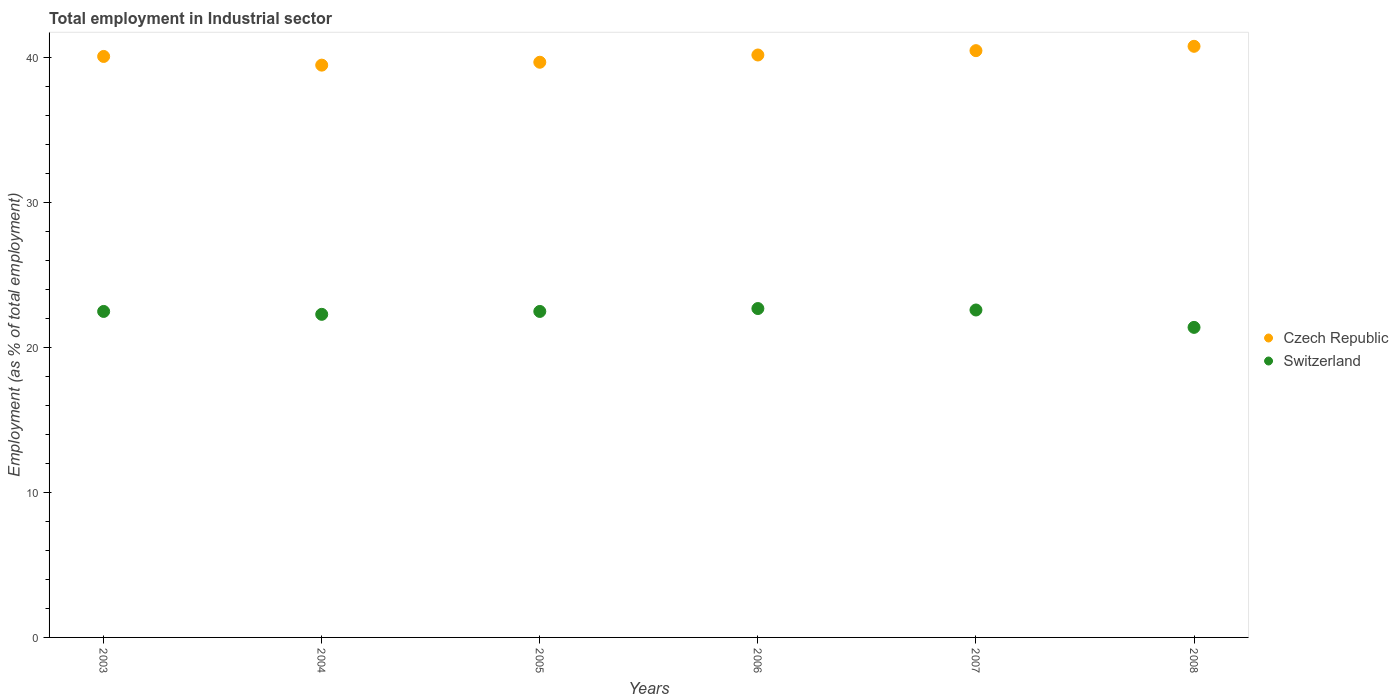What is the employment in industrial sector in Czech Republic in 2008?
Offer a very short reply. 40.8. Across all years, what is the maximum employment in industrial sector in Czech Republic?
Your response must be concise. 40.8. Across all years, what is the minimum employment in industrial sector in Switzerland?
Give a very brief answer. 21.4. In which year was the employment in industrial sector in Czech Republic maximum?
Offer a very short reply. 2008. What is the total employment in industrial sector in Czech Republic in the graph?
Offer a terse response. 240.8. What is the difference between the employment in industrial sector in Czech Republic in 2003 and that in 2008?
Your answer should be compact. -0.7. What is the difference between the employment in industrial sector in Czech Republic in 2004 and the employment in industrial sector in Switzerland in 2008?
Offer a very short reply. 18.1. What is the average employment in industrial sector in Czech Republic per year?
Provide a short and direct response. 40.13. In the year 2006, what is the difference between the employment in industrial sector in Czech Republic and employment in industrial sector in Switzerland?
Make the answer very short. 17.5. What is the ratio of the employment in industrial sector in Czech Republic in 2004 to that in 2005?
Give a very brief answer. 0.99. What is the difference between the highest and the second highest employment in industrial sector in Czech Republic?
Your answer should be compact. 0.3. What is the difference between the highest and the lowest employment in industrial sector in Switzerland?
Ensure brevity in your answer.  1.3. Is the sum of the employment in industrial sector in Switzerland in 2003 and 2005 greater than the maximum employment in industrial sector in Czech Republic across all years?
Provide a short and direct response. Yes. Is the employment in industrial sector in Switzerland strictly greater than the employment in industrial sector in Czech Republic over the years?
Make the answer very short. No. Is the employment in industrial sector in Czech Republic strictly less than the employment in industrial sector in Switzerland over the years?
Your response must be concise. No. How many years are there in the graph?
Offer a terse response. 6. Does the graph contain grids?
Make the answer very short. No. Where does the legend appear in the graph?
Your response must be concise. Center right. How many legend labels are there?
Give a very brief answer. 2. What is the title of the graph?
Provide a short and direct response. Total employment in Industrial sector. Does "Morocco" appear as one of the legend labels in the graph?
Provide a short and direct response. No. What is the label or title of the Y-axis?
Your answer should be very brief. Employment (as % of total employment). What is the Employment (as % of total employment) in Czech Republic in 2003?
Your response must be concise. 40.1. What is the Employment (as % of total employment) of Czech Republic in 2004?
Your response must be concise. 39.5. What is the Employment (as % of total employment) of Switzerland in 2004?
Provide a succinct answer. 22.3. What is the Employment (as % of total employment) of Czech Republic in 2005?
Ensure brevity in your answer.  39.7. What is the Employment (as % of total employment) of Czech Republic in 2006?
Give a very brief answer. 40.2. What is the Employment (as % of total employment) of Switzerland in 2006?
Ensure brevity in your answer.  22.7. What is the Employment (as % of total employment) of Czech Republic in 2007?
Keep it short and to the point. 40.5. What is the Employment (as % of total employment) of Switzerland in 2007?
Offer a very short reply. 22.6. What is the Employment (as % of total employment) in Czech Republic in 2008?
Ensure brevity in your answer.  40.8. What is the Employment (as % of total employment) in Switzerland in 2008?
Ensure brevity in your answer.  21.4. Across all years, what is the maximum Employment (as % of total employment) in Czech Republic?
Offer a terse response. 40.8. Across all years, what is the maximum Employment (as % of total employment) of Switzerland?
Your answer should be compact. 22.7. Across all years, what is the minimum Employment (as % of total employment) in Czech Republic?
Give a very brief answer. 39.5. Across all years, what is the minimum Employment (as % of total employment) of Switzerland?
Offer a terse response. 21.4. What is the total Employment (as % of total employment) in Czech Republic in the graph?
Ensure brevity in your answer.  240.8. What is the total Employment (as % of total employment) in Switzerland in the graph?
Offer a very short reply. 134. What is the difference between the Employment (as % of total employment) of Czech Republic in 2003 and that in 2004?
Offer a terse response. 0.6. What is the difference between the Employment (as % of total employment) of Switzerland in 2003 and that in 2004?
Your answer should be compact. 0.2. What is the difference between the Employment (as % of total employment) of Czech Republic in 2003 and that in 2005?
Give a very brief answer. 0.4. What is the difference between the Employment (as % of total employment) in Czech Republic in 2003 and that in 2007?
Provide a succinct answer. -0.4. What is the difference between the Employment (as % of total employment) of Switzerland in 2003 and that in 2007?
Ensure brevity in your answer.  -0.1. What is the difference between the Employment (as % of total employment) in Czech Republic in 2004 and that in 2005?
Make the answer very short. -0.2. What is the difference between the Employment (as % of total employment) of Switzerland in 2004 and that in 2006?
Ensure brevity in your answer.  -0.4. What is the difference between the Employment (as % of total employment) of Czech Republic in 2004 and that in 2007?
Provide a short and direct response. -1. What is the difference between the Employment (as % of total employment) in Switzerland in 2004 and that in 2007?
Provide a succinct answer. -0.3. What is the difference between the Employment (as % of total employment) in Switzerland in 2004 and that in 2008?
Offer a terse response. 0.9. What is the difference between the Employment (as % of total employment) in Switzerland in 2005 and that in 2006?
Ensure brevity in your answer.  -0.2. What is the difference between the Employment (as % of total employment) of Czech Republic in 2005 and that in 2007?
Offer a very short reply. -0.8. What is the difference between the Employment (as % of total employment) of Switzerland in 2005 and that in 2007?
Give a very brief answer. -0.1. What is the difference between the Employment (as % of total employment) of Switzerland in 2005 and that in 2008?
Your answer should be very brief. 1.1. What is the difference between the Employment (as % of total employment) in Czech Republic in 2007 and that in 2008?
Make the answer very short. -0.3. What is the difference between the Employment (as % of total employment) of Switzerland in 2007 and that in 2008?
Offer a very short reply. 1.2. What is the difference between the Employment (as % of total employment) of Czech Republic in 2003 and the Employment (as % of total employment) of Switzerland in 2004?
Provide a succinct answer. 17.8. What is the difference between the Employment (as % of total employment) of Czech Republic in 2003 and the Employment (as % of total employment) of Switzerland in 2007?
Offer a terse response. 17.5. What is the difference between the Employment (as % of total employment) of Czech Republic in 2003 and the Employment (as % of total employment) of Switzerland in 2008?
Your response must be concise. 18.7. What is the difference between the Employment (as % of total employment) in Czech Republic in 2004 and the Employment (as % of total employment) in Switzerland in 2005?
Your answer should be very brief. 17. What is the difference between the Employment (as % of total employment) in Czech Republic in 2004 and the Employment (as % of total employment) in Switzerland in 2007?
Your answer should be very brief. 16.9. What is the difference between the Employment (as % of total employment) of Czech Republic in 2006 and the Employment (as % of total employment) of Switzerland in 2008?
Offer a terse response. 18.8. What is the difference between the Employment (as % of total employment) in Czech Republic in 2007 and the Employment (as % of total employment) in Switzerland in 2008?
Provide a succinct answer. 19.1. What is the average Employment (as % of total employment) in Czech Republic per year?
Make the answer very short. 40.13. What is the average Employment (as % of total employment) in Switzerland per year?
Give a very brief answer. 22.33. In the year 2003, what is the difference between the Employment (as % of total employment) of Czech Republic and Employment (as % of total employment) of Switzerland?
Make the answer very short. 17.6. In the year 2004, what is the difference between the Employment (as % of total employment) in Czech Republic and Employment (as % of total employment) in Switzerland?
Offer a very short reply. 17.2. In the year 2007, what is the difference between the Employment (as % of total employment) of Czech Republic and Employment (as % of total employment) of Switzerland?
Provide a short and direct response. 17.9. In the year 2008, what is the difference between the Employment (as % of total employment) in Czech Republic and Employment (as % of total employment) in Switzerland?
Your response must be concise. 19.4. What is the ratio of the Employment (as % of total employment) in Czech Republic in 2003 to that in 2004?
Ensure brevity in your answer.  1.02. What is the ratio of the Employment (as % of total employment) in Czech Republic in 2003 to that in 2005?
Keep it short and to the point. 1.01. What is the ratio of the Employment (as % of total employment) in Switzerland in 2003 to that in 2005?
Offer a terse response. 1. What is the ratio of the Employment (as % of total employment) of Switzerland in 2003 to that in 2006?
Offer a very short reply. 0.99. What is the ratio of the Employment (as % of total employment) of Czech Republic in 2003 to that in 2007?
Provide a succinct answer. 0.99. What is the ratio of the Employment (as % of total employment) in Czech Republic in 2003 to that in 2008?
Keep it short and to the point. 0.98. What is the ratio of the Employment (as % of total employment) in Switzerland in 2003 to that in 2008?
Provide a succinct answer. 1.05. What is the ratio of the Employment (as % of total employment) of Czech Republic in 2004 to that in 2005?
Keep it short and to the point. 0.99. What is the ratio of the Employment (as % of total employment) of Switzerland in 2004 to that in 2005?
Offer a very short reply. 0.99. What is the ratio of the Employment (as % of total employment) of Czech Republic in 2004 to that in 2006?
Provide a succinct answer. 0.98. What is the ratio of the Employment (as % of total employment) of Switzerland in 2004 to that in 2006?
Give a very brief answer. 0.98. What is the ratio of the Employment (as % of total employment) of Czech Republic in 2004 to that in 2007?
Provide a succinct answer. 0.98. What is the ratio of the Employment (as % of total employment) in Switzerland in 2004 to that in 2007?
Your answer should be compact. 0.99. What is the ratio of the Employment (as % of total employment) of Czech Republic in 2004 to that in 2008?
Make the answer very short. 0.97. What is the ratio of the Employment (as % of total employment) of Switzerland in 2004 to that in 2008?
Offer a terse response. 1.04. What is the ratio of the Employment (as % of total employment) of Czech Republic in 2005 to that in 2006?
Your answer should be compact. 0.99. What is the ratio of the Employment (as % of total employment) in Czech Republic in 2005 to that in 2007?
Ensure brevity in your answer.  0.98. What is the ratio of the Employment (as % of total employment) of Switzerland in 2005 to that in 2007?
Make the answer very short. 1. What is the ratio of the Employment (as % of total employment) of Switzerland in 2005 to that in 2008?
Offer a very short reply. 1.05. What is the ratio of the Employment (as % of total employment) in Czech Republic in 2006 to that in 2007?
Provide a short and direct response. 0.99. What is the ratio of the Employment (as % of total employment) in Switzerland in 2006 to that in 2007?
Offer a terse response. 1. What is the ratio of the Employment (as % of total employment) of Switzerland in 2006 to that in 2008?
Offer a terse response. 1.06. What is the ratio of the Employment (as % of total employment) in Czech Republic in 2007 to that in 2008?
Make the answer very short. 0.99. What is the ratio of the Employment (as % of total employment) of Switzerland in 2007 to that in 2008?
Provide a short and direct response. 1.06. What is the difference between the highest and the second highest Employment (as % of total employment) in Czech Republic?
Ensure brevity in your answer.  0.3. 